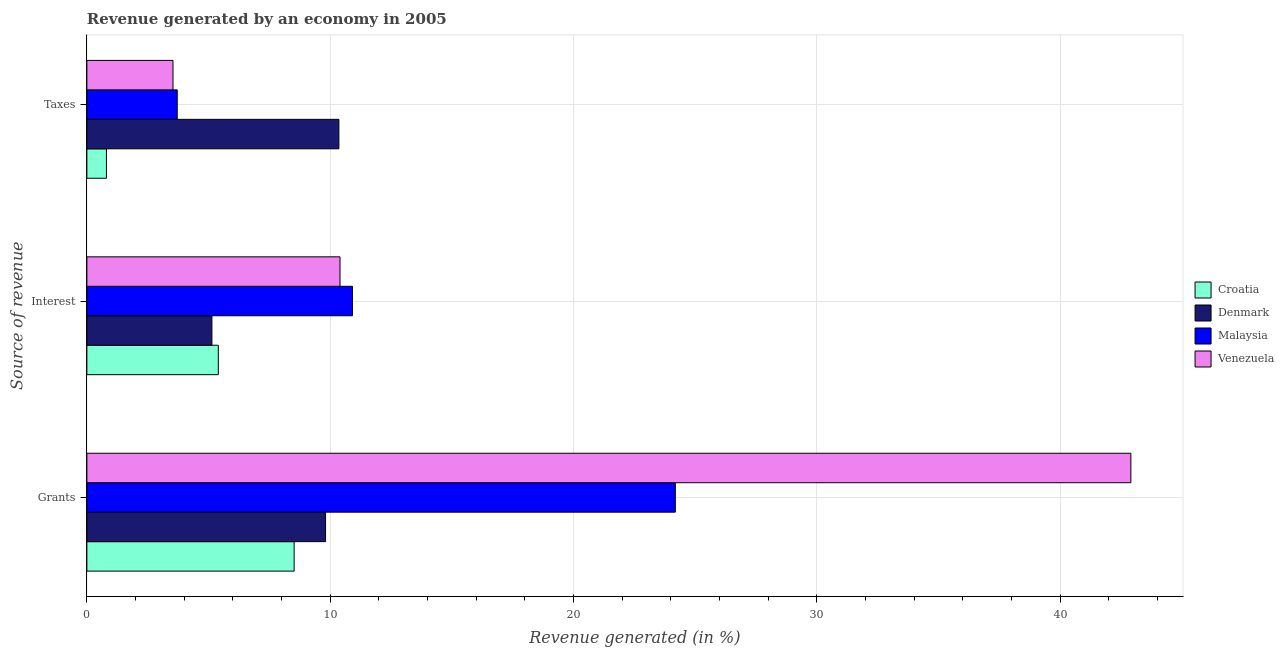How many different coloured bars are there?
Your answer should be compact. 4. Are the number of bars per tick equal to the number of legend labels?
Offer a very short reply. Yes. How many bars are there on the 1st tick from the top?
Make the answer very short. 4. How many bars are there on the 1st tick from the bottom?
Your response must be concise. 4. What is the label of the 1st group of bars from the top?
Offer a terse response. Taxes. What is the percentage of revenue generated by interest in Denmark?
Ensure brevity in your answer.  5.14. Across all countries, what is the maximum percentage of revenue generated by taxes?
Offer a terse response. 10.36. Across all countries, what is the minimum percentage of revenue generated by grants?
Your response must be concise. 8.52. In which country was the percentage of revenue generated by interest maximum?
Make the answer very short. Malaysia. In which country was the percentage of revenue generated by grants minimum?
Ensure brevity in your answer.  Croatia. What is the total percentage of revenue generated by interest in the graph?
Your answer should be very brief. 31.86. What is the difference between the percentage of revenue generated by taxes in Denmark and that in Venezuela?
Provide a short and direct response. 6.82. What is the difference between the percentage of revenue generated by taxes in Croatia and the percentage of revenue generated by interest in Venezuela?
Provide a succinct answer. -9.6. What is the average percentage of revenue generated by taxes per country?
Provide a short and direct response. 4.6. What is the difference between the percentage of revenue generated by grants and percentage of revenue generated by taxes in Croatia?
Ensure brevity in your answer.  7.72. What is the ratio of the percentage of revenue generated by interest in Croatia to that in Malaysia?
Offer a very short reply. 0.49. Is the difference between the percentage of revenue generated by taxes in Venezuela and Malaysia greater than the difference between the percentage of revenue generated by grants in Venezuela and Malaysia?
Your answer should be very brief. No. What is the difference between the highest and the second highest percentage of revenue generated by grants?
Your response must be concise. 18.72. What is the difference between the highest and the lowest percentage of revenue generated by taxes?
Offer a terse response. 9.55. In how many countries, is the percentage of revenue generated by taxes greater than the average percentage of revenue generated by taxes taken over all countries?
Your response must be concise. 1. What does the 2nd bar from the top in Interest represents?
Make the answer very short. Malaysia. What does the 3rd bar from the bottom in Grants represents?
Make the answer very short. Malaysia. Is it the case that in every country, the sum of the percentage of revenue generated by grants and percentage of revenue generated by interest is greater than the percentage of revenue generated by taxes?
Provide a succinct answer. Yes. How many bars are there?
Give a very brief answer. 12. Are all the bars in the graph horizontal?
Offer a very short reply. Yes. How many countries are there in the graph?
Give a very brief answer. 4. What is the title of the graph?
Offer a terse response. Revenue generated by an economy in 2005. Does "Morocco" appear as one of the legend labels in the graph?
Keep it short and to the point. No. What is the label or title of the X-axis?
Your answer should be very brief. Revenue generated (in %). What is the label or title of the Y-axis?
Provide a succinct answer. Source of revenue. What is the Revenue generated (in %) in Croatia in Grants?
Your response must be concise. 8.52. What is the Revenue generated (in %) in Denmark in Grants?
Your answer should be compact. 9.81. What is the Revenue generated (in %) in Malaysia in Grants?
Offer a terse response. 24.19. What is the Revenue generated (in %) in Venezuela in Grants?
Ensure brevity in your answer.  42.91. What is the Revenue generated (in %) in Croatia in Interest?
Ensure brevity in your answer.  5.4. What is the Revenue generated (in %) of Denmark in Interest?
Give a very brief answer. 5.14. What is the Revenue generated (in %) of Malaysia in Interest?
Make the answer very short. 10.92. What is the Revenue generated (in %) in Venezuela in Interest?
Your answer should be very brief. 10.4. What is the Revenue generated (in %) in Croatia in Taxes?
Offer a terse response. 0.8. What is the Revenue generated (in %) of Denmark in Taxes?
Ensure brevity in your answer.  10.36. What is the Revenue generated (in %) of Malaysia in Taxes?
Ensure brevity in your answer.  3.71. What is the Revenue generated (in %) of Venezuela in Taxes?
Offer a very short reply. 3.54. Across all Source of revenue, what is the maximum Revenue generated (in %) in Croatia?
Your answer should be very brief. 8.52. Across all Source of revenue, what is the maximum Revenue generated (in %) in Denmark?
Offer a terse response. 10.36. Across all Source of revenue, what is the maximum Revenue generated (in %) of Malaysia?
Give a very brief answer. 24.19. Across all Source of revenue, what is the maximum Revenue generated (in %) of Venezuela?
Provide a short and direct response. 42.91. Across all Source of revenue, what is the minimum Revenue generated (in %) in Croatia?
Your answer should be very brief. 0.8. Across all Source of revenue, what is the minimum Revenue generated (in %) in Denmark?
Offer a terse response. 5.14. Across all Source of revenue, what is the minimum Revenue generated (in %) of Malaysia?
Offer a very short reply. 3.71. Across all Source of revenue, what is the minimum Revenue generated (in %) in Venezuela?
Offer a very short reply. 3.54. What is the total Revenue generated (in %) in Croatia in the graph?
Make the answer very short. 14.72. What is the total Revenue generated (in %) in Denmark in the graph?
Provide a succinct answer. 25.31. What is the total Revenue generated (in %) of Malaysia in the graph?
Give a very brief answer. 38.81. What is the total Revenue generated (in %) of Venezuela in the graph?
Offer a very short reply. 56.85. What is the difference between the Revenue generated (in %) in Croatia in Grants and that in Interest?
Your answer should be compact. 3.12. What is the difference between the Revenue generated (in %) in Denmark in Grants and that in Interest?
Your answer should be compact. 4.67. What is the difference between the Revenue generated (in %) of Malaysia in Grants and that in Interest?
Ensure brevity in your answer.  13.27. What is the difference between the Revenue generated (in %) in Venezuela in Grants and that in Interest?
Provide a short and direct response. 32.5. What is the difference between the Revenue generated (in %) of Croatia in Grants and that in Taxes?
Keep it short and to the point. 7.72. What is the difference between the Revenue generated (in %) in Denmark in Grants and that in Taxes?
Your response must be concise. -0.55. What is the difference between the Revenue generated (in %) of Malaysia in Grants and that in Taxes?
Your response must be concise. 20.47. What is the difference between the Revenue generated (in %) of Venezuela in Grants and that in Taxes?
Give a very brief answer. 39.37. What is the difference between the Revenue generated (in %) in Croatia in Interest and that in Taxes?
Provide a succinct answer. 4.6. What is the difference between the Revenue generated (in %) in Denmark in Interest and that in Taxes?
Provide a short and direct response. -5.22. What is the difference between the Revenue generated (in %) in Malaysia in Interest and that in Taxes?
Make the answer very short. 7.2. What is the difference between the Revenue generated (in %) of Venezuela in Interest and that in Taxes?
Provide a succinct answer. 6.86. What is the difference between the Revenue generated (in %) in Croatia in Grants and the Revenue generated (in %) in Denmark in Interest?
Provide a succinct answer. 3.38. What is the difference between the Revenue generated (in %) in Croatia in Grants and the Revenue generated (in %) in Malaysia in Interest?
Your answer should be compact. -2.4. What is the difference between the Revenue generated (in %) in Croatia in Grants and the Revenue generated (in %) in Venezuela in Interest?
Provide a short and direct response. -1.89. What is the difference between the Revenue generated (in %) of Denmark in Grants and the Revenue generated (in %) of Malaysia in Interest?
Provide a short and direct response. -1.11. What is the difference between the Revenue generated (in %) of Denmark in Grants and the Revenue generated (in %) of Venezuela in Interest?
Keep it short and to the point. -0.59. What is the difference between the Revenue generated (in %) in Malaysia in Grants and the Revenue generated (in %) in Venezuela in Interest?
Provide a succinct answer. 13.78. What is the difference between the Revenue generated (in %) in Croatia in Grants and the Revenue generated (in %) in Denmark in Taxes?
Offer a terse response. -1.84. What is the difference between the Revenue generated (in %) in Croatia in Grants and the Revenue generated (in %) in Malaysia in Taxes?
Your answer should be very brief. 4.81. What is the difference between the Revenue generated (in %) in Croatia in Grants and the Revenue generated (in %) in Venezuela in Taxes?
Ensure brevity in your answer.  4.98. What is the difference between the Revenue generated (in %) in Denmark in Grants and the Revenue generated (in %) in Malaysia in Taxes?
Offer a very short reply. 6.1. What is the difference between the Revenue generated (in %) of Denmark in Grants and the Revenue generated (in %) of Venezuela in Taxes?
Provide a succinct answer. 6.27. What is the difference between the Revenue generated (in %) of Malaysia in Grants and the Revenue generated (in %) of Venezuela in Taxes?
Offer a terse response. 20.65. What is the difference between the Revenue generated (in %) in Croatia in Interest and the Revenue generated (in %) in Denmark in Taxes?
Offer a very short reply. -4.96. What is the difference between the Revenue generated (in %) in Croatia in Interest and the Revenue generated (in %) in Malaysia in Taxes?
Provide a short and direct response. 1.69. What is the difference between the Revenue generated (in %) in Croatia in Interest and the Revenue generated (in %) in Venezuela in Taxes?
Your response must be concise. 1.86. What is the difference between the Revenue generated (in %) of Denmark in Interest and the Revenue generated (in %) of Malaysia in Taxes?
Provide a short and direct response. 1.43. What is the difference between the Revenue generated (in %) in Denmark in Interest and the Revenue generated (in %) in Venezuela in Taxes?
Your answer should be very brief. 1.6. What is the difference between the Revenue generated (in %) of Malaysia in Interest and the Revenue generated (in %) of Venezuela in Taxes?
Offer a very short reply. 7.38. What is the average Revenue generated (in %) of Croatia per Source of revenue?
Keep it short and to the point. 4.91. What is the average Revenue generated (in %) in Denmark per Source of revenue?
Your answer should be compact. 8.44. What is the average Revenue generated (in %) of Malaysia per Source of revenue?
Provide a short and direct response. 12.94. What is the average Revenue generated (in %) of Venezuela per Source of revenue?
Offer a very short reply. 18.95. What is the difference between the Revenue generated (in %) of Croatia and Revenue generated (in %) of Denmark in Grants?
Keep it short and to the point. -1.29. What is the difference between the Revenue generated (in %) of Croatia and Revenue generated (in %) of Malaysia in Grants?
Provide a succinct answer. -15.67. What is the difference between the Revenue generated (in %) of Croatia and Revenue generated (in %) of Venezuela in Grants?
Give a very brief answer. -34.39. What is the difference between the Revenue generated (in %) in Denmark and Revenue generated (in %) in Malaysia in Grants?
Offer a terse response. -14.38. What is the difference between the Revenue generated (in %) in Denmark and Revenue generated (in %) in Venezuela in Grants?
Ensure brevity in your answer.  -33.1. What is the difference between the Revenue generated (in %) of Malaysia and Revenue generated (in %) of Venezuela in Grants?
Give a very brief answer. -18.72. What is the difference between the Revenue generated (in %) of Croatia and Revenue generated (in %) of Denmark in Interest?
Provide a short and direct response. 0.26. What is the difference between the Revenue generated (in %) in Croatia and Revenue generated (in %) in Malaysia in Interest?
Provide a succinct answer. -5.51. What is the difference between the Revenue generated (in %) in Croatia and Revenue generated (in %) in Venezuela in Interest?
Keep it short and to the point. -5. What is the difference between the Revenue generated (in %) of Denmark and Revenue generated (in %) of Malaysia in Interest?
Offer a terse response. -5.78. What is the difference between the Revenue generated (in %) in Denmark and Revenue generated (in %) in Venezuela in Interest?
Offer a very short reply. -5.26. What is the difference between the Revenue generated (in %) in Malaysia and Revenue generated (in %) in Venezuela in Interest?
Your response must be concise. 0.51. What is the difference between the Revenue generated (in %) of Croatia and Revenue generated (in %) of Denmark in Taxes?
Ensure brevity in your answer.  -9.55. What is the difference between the Revenue generated (in %) in Croatia and Revenue generated (in %) in Malaysia in Taxes?
Offer a very short reply. -2.91. What is the difference between the Revenue generated (in %) of Croatia and Revenue generated (in %) of Venezuela in Taxes?
Your answer should be compact. -2.74. What is the difference between the Revenue generated (in %) of Denmark and Revenue generated (in %) of Malaysia in Taxes?
Provide a succinct answer. 6.64. What is the difference between the Revenue generated (in %) of Denmark and Revenue generated (in %) of Venezuela in Taxes?
Offer a very short reply. 6.82. What is the difference between the Revenue generated (in %) in Malaysia and Revenue generated (in %) in Venezuela in Taxes?
Provide a succinct answer. 0.17. What is the ratio of the Revenue generated (in %) in Croatia in Grants to that in Interest?
Provide a short and direct response. 1.58. What is the ratio of the Revenue generated (in %) of Denmark in Grants to that in Interest?
Offer a very short reply. 1.91. What is the ratio of the Revenue generated (in %) in Malaysia in Grants to that in Interest?
Offer a very short reply. 2.22. What is the ratio of the Revenue generated (in %) of Venezuela in Grants to that in Interest?
Make the answer very short. 4.12. What is the ratio of the Revenue generated (in %) of Croatia in Grants to that in Taxes?
Your answer should be very brief. 10.6. What is the ratio of the Revenue generated (in %) in Denmark in Grants to that in Taxes?
Offer a terse response. 0.95. What is the ratio of the Revenue generated (in %) of Malaysia in Grants to that in Taxes?
Keep it short and to the point. 6.51. What is the ratio of the Revenue generated (in %) in Venezuela in Grants to that in Taxes?
Provide a short and direct response. 12.12. What is the ratio of the Revenue generated (in %) of Croatia in Interest to that in Taxes?
Make the answer very short. 6.72. What is the ratio of the Revenue generated (in %) in Denmark in Interest to that in Taxes?
Your answer should be very brief. 0.5. What is the ratio of the Revenue generated (in %) of Malaysia in Interest to that in Taxes?
Offer a terse response. 2.94. What is the ratio of the Revenue generated (in %) of Venezuela in Interest to that in Taxes?
Make the answer very short. 2.94. What is the difference between the highest and the second highest Revenue generated (in %) in Croatia?
Provide a short and direct response. 3.12. What is the difference between the highest and the second highest Revenue generated (in %) in Denmark?
Your answer should be very brief. 0.55. What is the difference between the highest and the second highest Revenue generated (in %) of Malaysia?
Your answer should be very brief. 13.27. What is the difference between the highest and the second highest Revenue generated (in %) in Venezuela?
Offer a very short reply. 32.5. What is the difference between the highest and the lowest Revenue generated (in %) in Croatia?
Offer a terse response. 7.72. What is the difference between the highest and the lowest Revenue generated (in %) of Denmark?
Give a very brief answer. 5.22. What is the difference between the highest and the lowest Revenue generated (in %) of Malaysia?
Provide a succinct answer. 20.47. What is the difference between the highest and the lowest Revenue generated (in %) in Venezuela?
Provide a succinct answer. 39.37. 